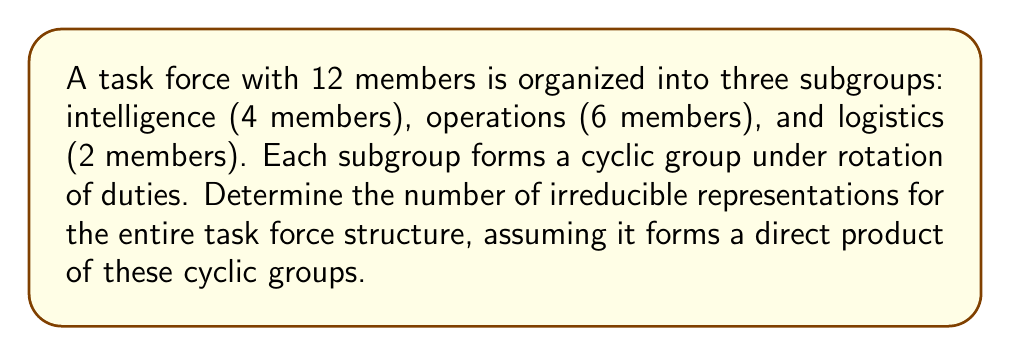Solve this math problem. To solve this problem, we'll follow these steps:

1) First, identify the group structure:
   The task force is organized as a direct product of three cyclic groups:
   $G = C_4 \times C_6 \times C_2$

2) Recall that for a direct product of groups, the number of irreducible representations is the product of the number of irreducible representations of each group.

3) For a cyclic group $C_n$, the number of irreducible representations is always equal to $n$.

4) Therefore, we need to calculate:
   $|Irr(C_4)| \cdot |Irr(C_6)| \cdot |Irr(C_2)|$

5) Substituting the values:
   $4 \cdot 6 \cdot 2$

6) Compute the final result:
   $4 \cdot 6 \cdot 2 = 24 \cdot 2 = 48$

Thus, the task force organizational structure has 48 irreducible representations.
Answer: 48 